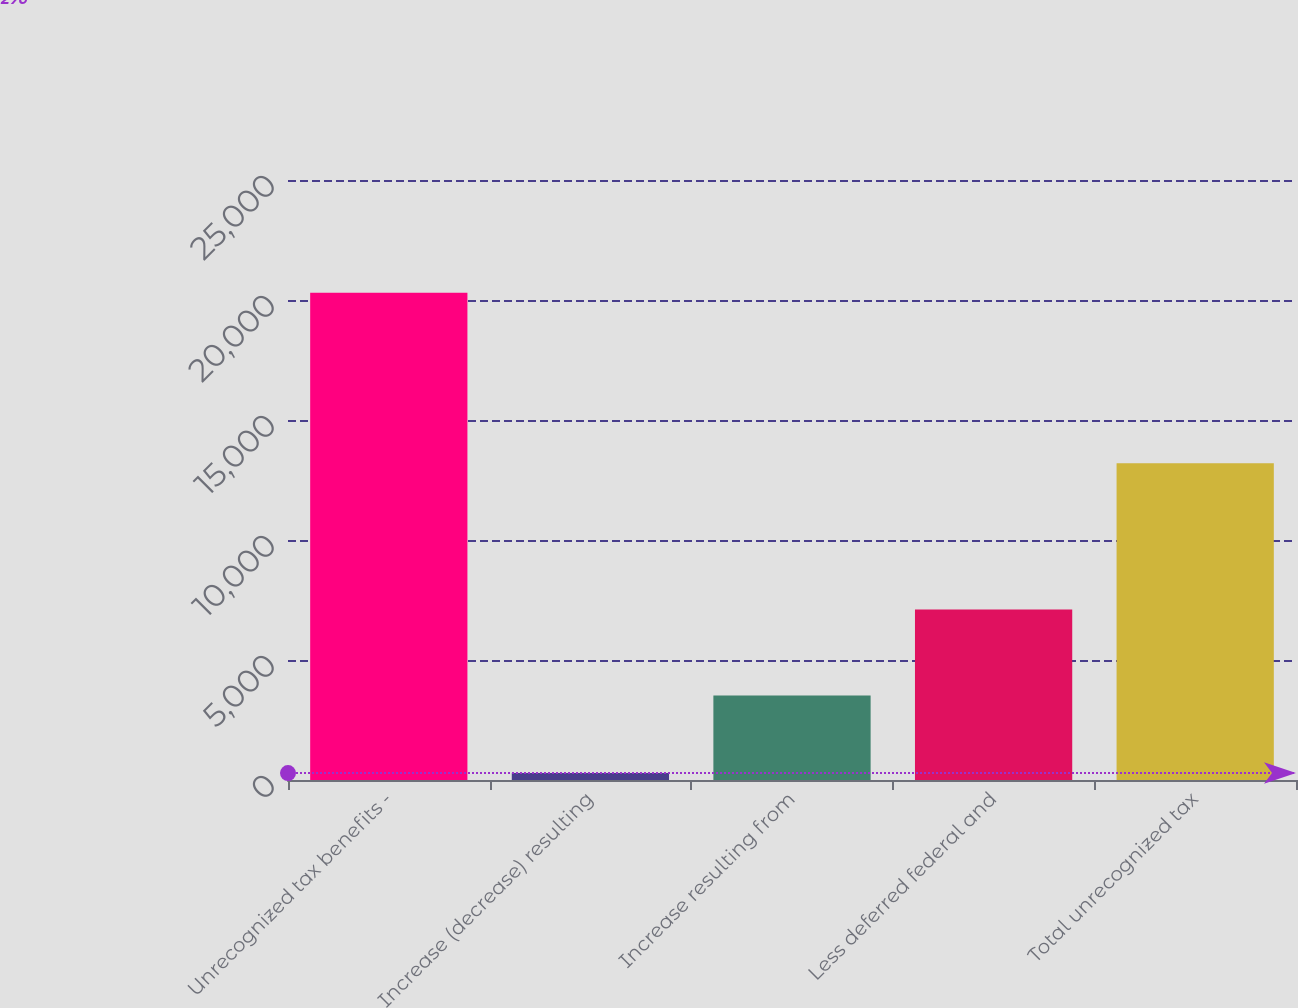<chart> <loc_0><loc_0><loc_500><loc_500><bar_chart><fcel>Unrecognized tax benefits -<fcel>Increase (decrease) resulting<fcel>Increase resulting from<fcel>Less deferred federal and<fcel>Total unrecognized tax<nl><fcel>20298<fcel>290<fcel>3519<fcel>7104<fcel>13194<nl></chart> 